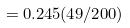<formula> <loc_0><loc_0><loc_500><loc_500>= 0 . 2 4 5 ( 4 9 / 2 0 0 )</formula> 